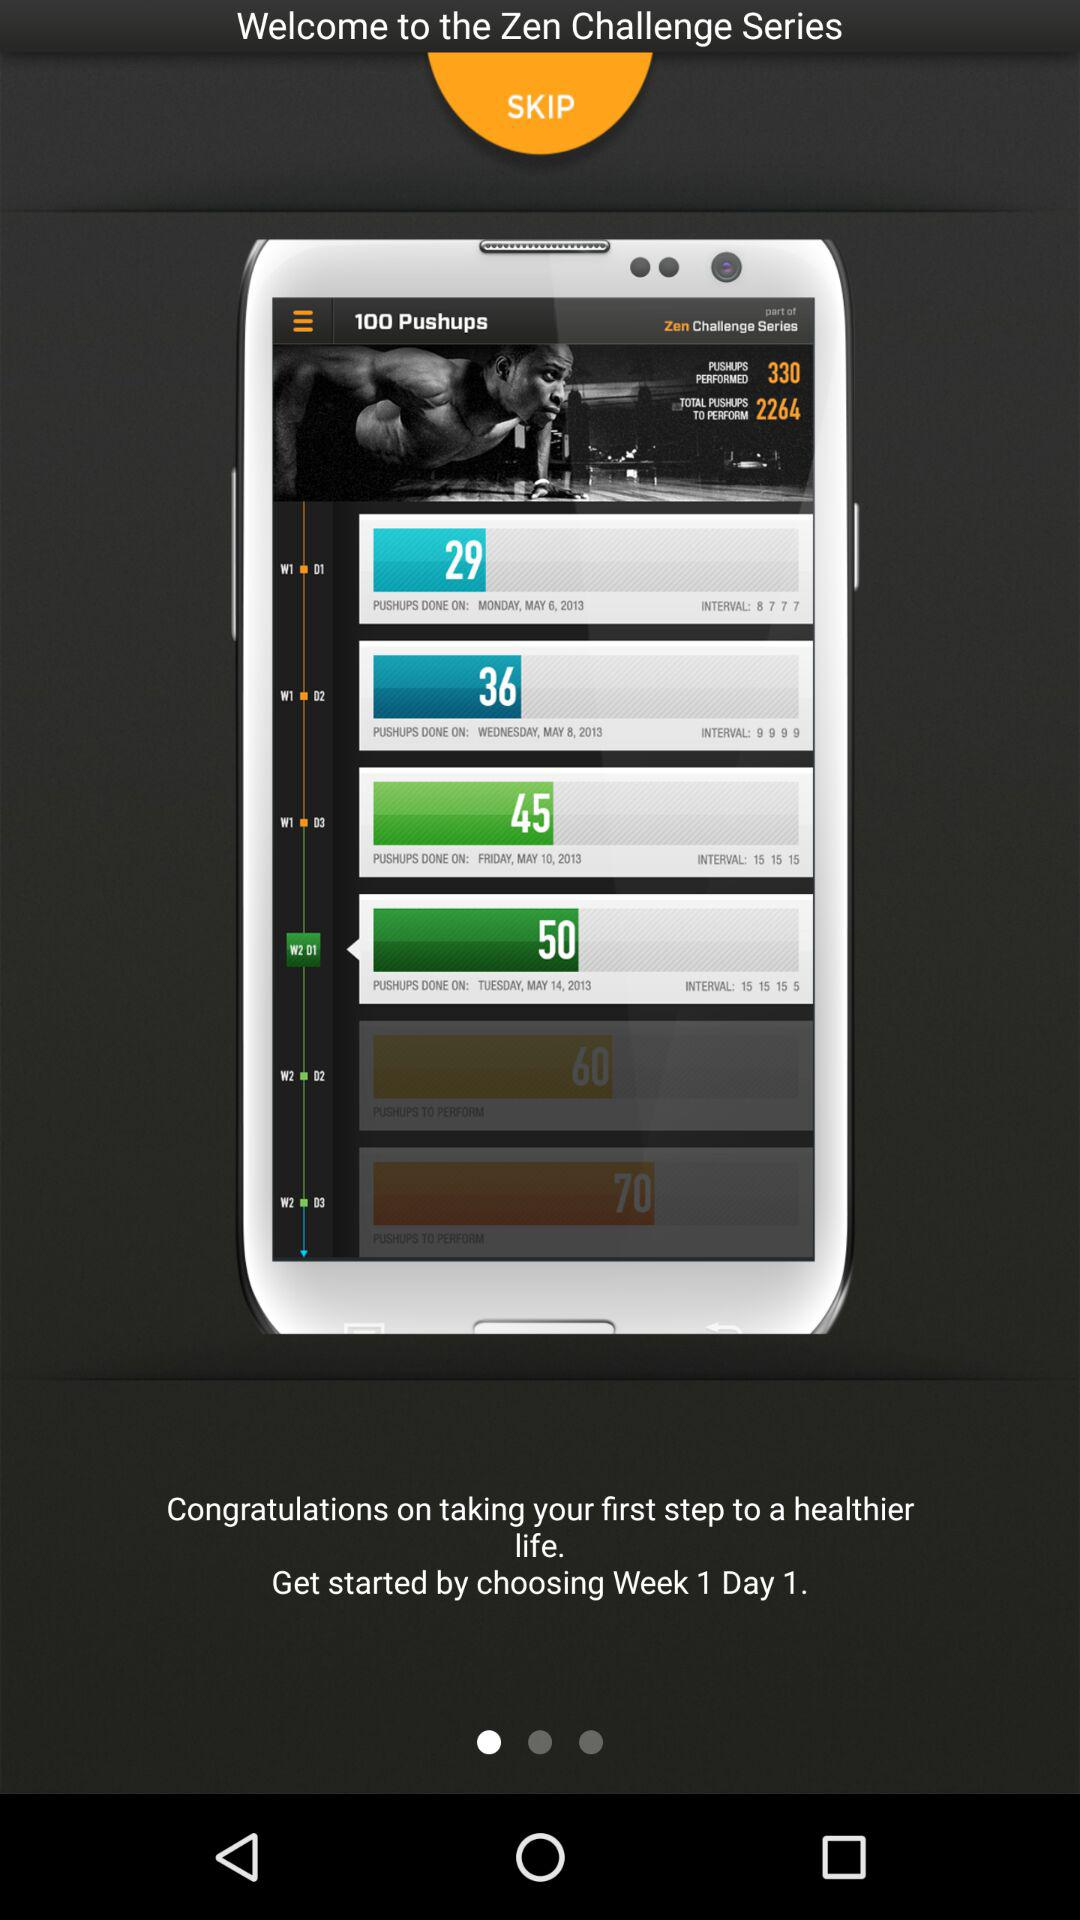What is the duration would have be choosed?
When the provided information is insufficient, respond with <no answer>. <no answer> 